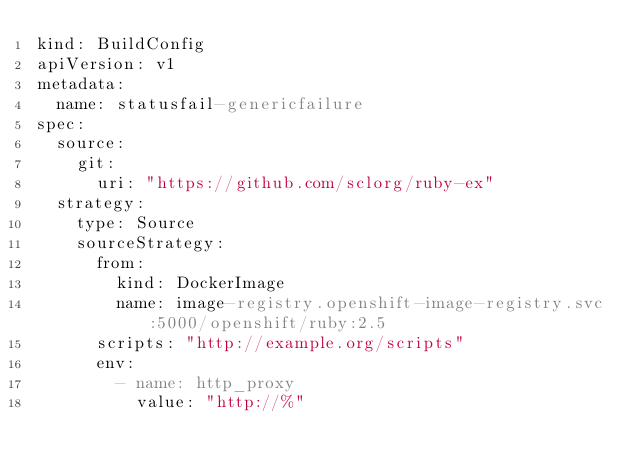Convert code to text. <code><loc_0><loc_0><loc_500><loc_500><_YAML_>kind: BuildConfig
apiVersion: v1
metadata:
  name: statusfail-genericfailure
spec:
  source:
    git:
      uri: "https://github.com/sclorg/ruby-ex"
  strategy:
    type: Source
    sourceStrategy:
      from:
        kind: DockerImage
        name: image-registry.openshift-image-registry.svc:5000/openshift/ruby:2.5
      scripts: "http://example.org/scripts"
      env:
        - name: http_proxy
          value: "http://%"
</code> 